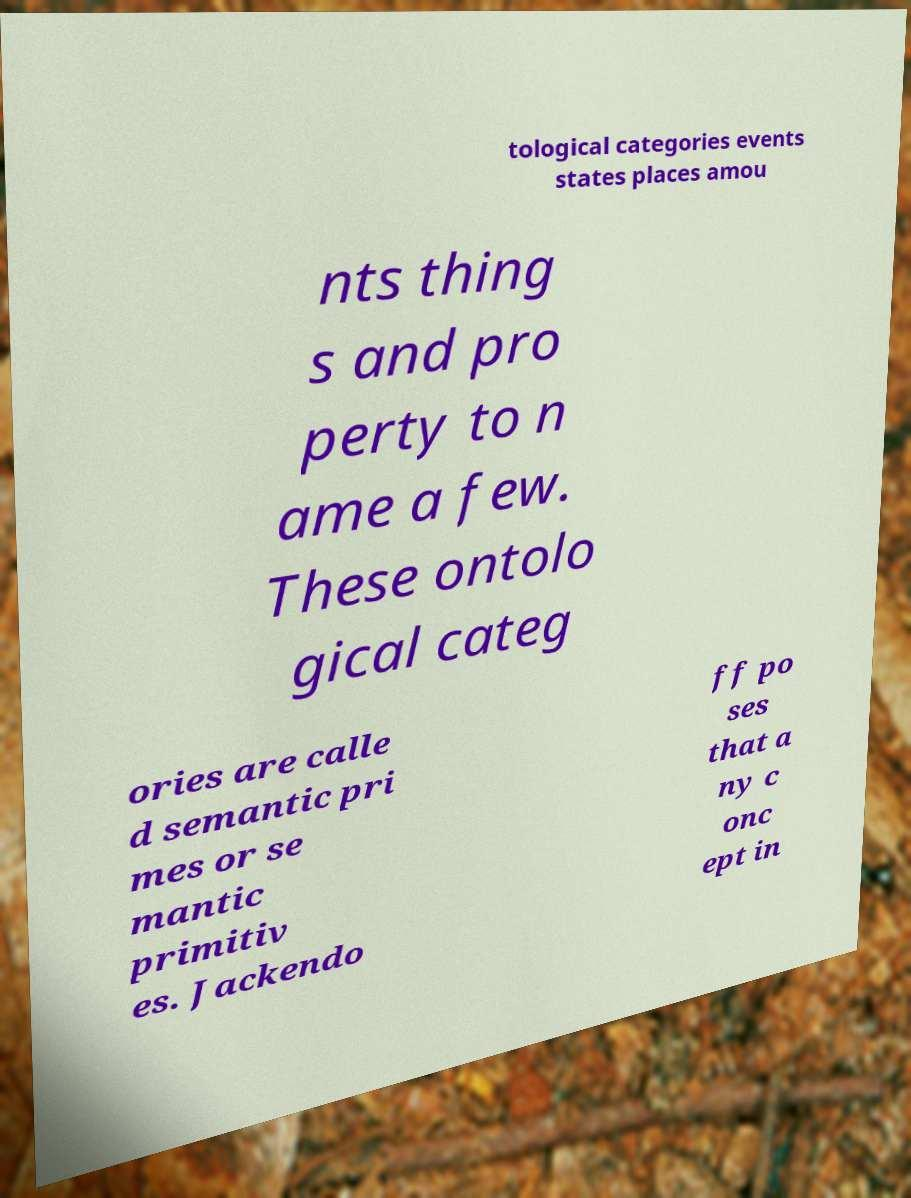I need the written content from this picture converted into text. Can you do that? tological categories events states places amou nts thing s and pro perty to n ame a few. These ontolo gical categ ories are calle d semantic pri mes or se mantic primitiv es. Jackendo ff po ses that a ny c onc ept in 